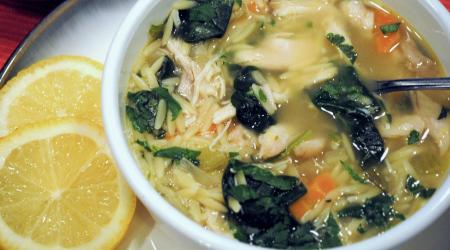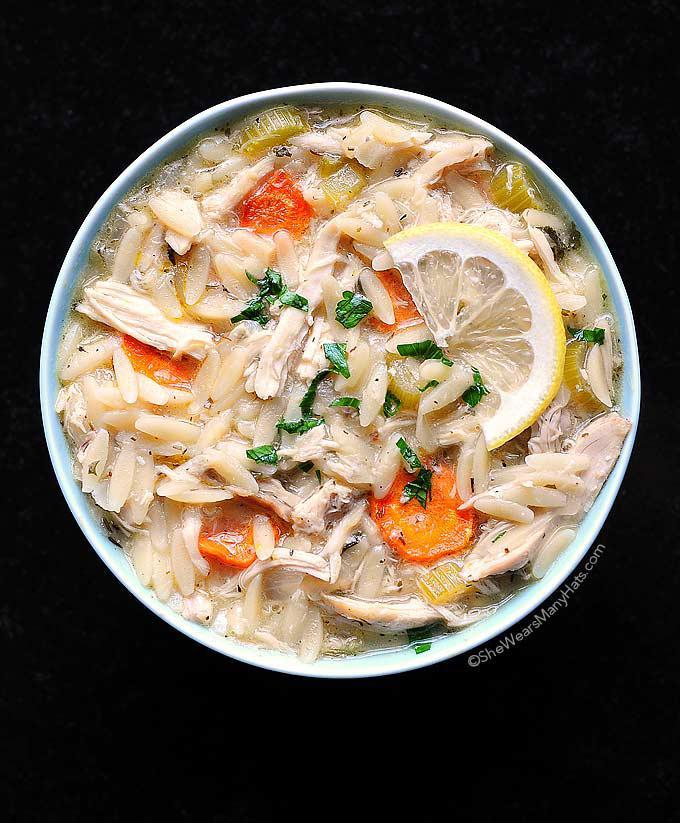The first image is the image on the left, the second image is the image on the right. Given the left and right images, does the statement "There are two lemon slices to the right of a white bowl with soap." hold true? Answer yes or no. Yes. 